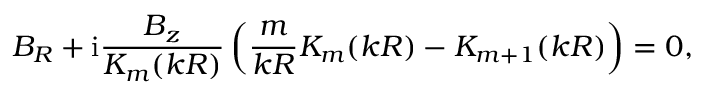Convert formula to latex. <formula><loc_0><loc_0><loc_500><loc_500>B _ { R } + i \frac { B _ { z } } { K _ { m } ( k R ) } \left ( \frac { m } { k R } K _ { m } ( k R ) - K _ { m + 1 } ( k R ) \right ) = 0 ,</formula> 